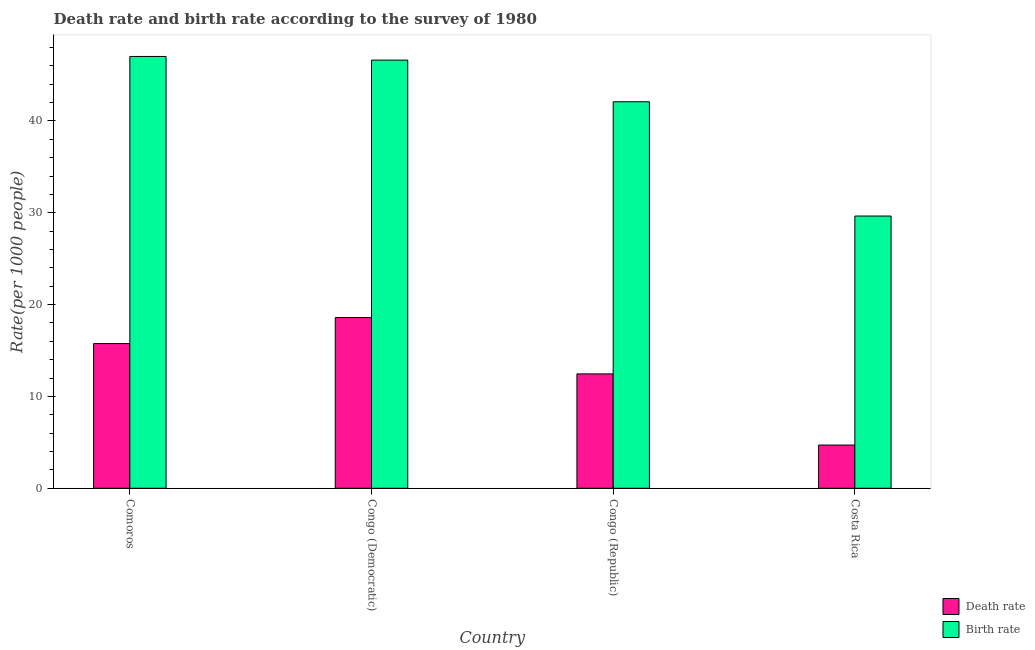Are the number of bars per tick equal to the number of legend labels?
Your answer should be very brief. Yes. Are the number of bars on each tick of the X-axis equal?
Your answer should be compact. Yes. How many bars are there on the 1st tick from the right?
Offer a very short reply. 2. What is the label of the 4th group of bars from the left?
Ensure brevity in your answer.  Costa Rica. What is the death rate in Costa Rica?
Offer a very short reply. 4.71. Across all countries, what is the maximum birth rate?
Ensure brevity in your answer.  47.03. Across all countries, what is the minimum death rate?
Ensure brevity in your answer.  4.71. In which country was the birth rate maximum?
Give a very brief answer. Comoros. What is the total birth rate in the graph?
Your answer should be compact. 165.4. What is the difference between the birth rate in Congo (Democratic) and that in Congo (Republic)?
Provide a short and direct response. 4.53. What is the difference between the death rate in Congo (Republic) and the birth rate in Costa Rica?
Your response must be concise. -17.19. What is the average birth rate per country?
Your answer should be very brief. 41.35. What is the difference between the death rate and birth rate in Comoros?
Offer a very short reply. -31.27. In how many countries, is the birth rate greater than 36 ?
Provide a short and direct response. 3. What is the ratio of the death rate in Comoros to that in Congo (Democratic)?
Your answer should be very brief. 0.85. What is the difference between the highest and the second highest birth rate?
Give a very brief answer. 0.4. What is the difference between the highest and the lowest birth rate?
Provide a short and direct response. 17.38. What does the 1st bar from the left in Congo (Democratic) represents?
Your response must be concise. Death rate. What does the 2nd bar from the right in Congo (Republic) represents?
Your answer should be very brief. Death rate. Are all the bars in the graph horizontal?
Ensure brevity in your answer.  No. How many countries are there in the graph?
Your answer should be very brief. 4. What is the difference between two consecutive major ticks on the Y-axis?
Your answer should be compact. 10. Does the graph contain any zero values?
Your response must be concise. No. Does the graph contain grids?
Offer a terse response. No. Where does the legend appear in the graph?
Offer a very short reply. Bottom right. How are the legend labels stacked?
Provide a short and direct response. Vertical. What is the title of the graph?
Keep it short and to the point. Death rate and birth rate according to the survey of 1980. Does "Agricultural land" appear as one of the legend labels in the graph?
Provide a succinct answer. No. What is the label or title of the Y-axis?
Offer a very short reply. Rate(per 1000 people). What is the Rate(per 1000 people) of Death rate in Comoros?
Give a very brief answer. 15.76. What is the Rate(per 1000 people) in Birth rate in Comoros?
Offer a very short reply. 47.03. What is the Rate(per 1000 people) in Death rate in Congo (Democratic)?
Ensure brevity in your answer.  18.6. What is the Rate(per 1000 people) of Birth rate in Congo (Democratic)?
Offer a terse response. 46.63. What is the Rate(per 1000 people) of Death rate in Congo (Republic)?
Provide a short and direct response. 12.46. What is the Rate(per 1000 people) of Birth rate in Congo (Republic)?
Provide a succinct answer. 42.09. What is the Rate(per 1000 people) of Death rate in Costa Rica?
Your answer should be compact. 4.71. What is the Rate(per 1000 people) in Birth rate in Costa Rica?
Offer a very short reply. 29.65. Across all countries, what is the maximum Rate(per 1000 people) in Death rate?
Ensure brevity in your answer.  18.6. Across all countries, what is the maximum Rate(per 1000 people) in Birth rate?
Your response must be concise. 47.03. Across all countries, what is the minimum Rate(per 1000 people) of Death rate?
Your answer should be very brief. 4.71. Across all countries, what is the minimum Rate(per 1000 people) of Birth rate?
Your answer should be compact. 29.65. What is the total Rate(per 1000 people) of Death rate in the graph?
Ensure brevity in your answer.  51.52. What is the total Rate(per 1000 people) in Birth rate in the graph?
Provide a short and direct response. 165.4. What is the difference between the Rate(per 1000 people) in Death rate in Comoros and that in Congo (Democratic)?
Offer a terse response. -2.84. What is the difference between the Rate(per 1000 people) of Birth rate in Comoros and that in Congo (Democratic)?
Give a very brief answer. 0.4. What is the difference between the Rate(per 1000 people) in Death rate in Comoros and that in Congo (Republic)?
Your answer should be compact. 3.3. What is the difference between the Rate(per 1000 people) in Birth rate in Comoros and that in Congo (Republic)?
Your answer should be compact. 4.93. What is the difference between the Rate(per 1000 people) in Death rate in Comoros and that in Costa Rica?
Give a very brief answer. 11.05. What is the difference between the Rate(per 1000 people) in Birth rate in Comoros and that in Costa Rica?
Your response must be concise. 17.38. What is the difference between the Rate(per 1000 people) of Death rate in Congo (Democratic) and that in Congo (Republic)?
Ensure brevity in your answer.  6.14. What is the difference between the Rate(per 1000 people) of Birth rate in Congo (Democratic) and that in Congo (Republic)?
Provide a short and direct response. 4.54. What is the difference between the Rate(per 1000 people) of Death rate in Congo (Democratic) and that in Costa Rica?
Provide a succinct answer. 13.89. What is the difference between the Rate(per 1000 people) of Birth rate in Congo (Democratic) and that in Costa Rica?
Keep it short and to the point. 16.98. What is the difference between the Rate(per 1000 people) in Death rate in Congo (Republic) and that in Costa Rica?
Your answer should be very brief. 7.75. What is the difference between the Rate(per 1000 people) of Birth rate in Congo (Republic) and that in Costa Rica?
Your answer should be compact. 12.45. What is the difference between the Rate(per 1000 people) of Death rate in Comoros and the Rate(per 1000 people) of Birth rate in Congo (Democratic)?
Provide a succinct answer. -30.87. What is the difference between the Rate(per 1000 people) of Death rate in Comoros and the Rate(per 1000 people) of Birth rate in Congo (Republic)?
Provide a succinct answer. -26.34. What is the difference between the Rate(per 1000 people) of Death rate in Comoros and the Rate(per 1000 people) of Birth rate in Costa Rica?
Make the answer very short. -13.89. What is the difference between the Rate(per 1000 people) of Death rate in Congo (Democratic) and the Rate(per 1000 people) of Birth rate in Congo (Republic)?
Your response must be concise. -23.5. What is the difference between the Rate(per 1000 people) in Death rate in Congo (Democratic) and the Rate(per 1000 people) in Birth rate in Costa Rica?
Ensure brevity in your answer.  -11.05. What is the difference between the Rate(per 1000 people) of Death rate in Congo (Republic) and the Rate(per 1000 people) of Birth rate in Costa Rica?
Provide a short and direct response. -17.19. What is the average Rate(per 1000 people) of Death rate per country?
Ensure brevity in your answer.  12.88. What is the average Rate(per 1000 people) in Birth rate per country?
Offer a very short reply. 41.35. What is the difference between the Rate(per 1000 people) in Death rate and Rate(per 1000 people) in Birth rate in Comoros?
Make the answer very short. -31.27. What is the difference between the Rate(per 1000 people) of Death rate and Rate(per 1000 people) of Birth rate in Congo (Democratic)?
Offer a terse response. -28.03. What is the difference between the Rate(per 1000 people) in Death rate and Rate(per 1000 people) in Birth rate in Congo (Republic)?
Provide a succinct answer. -29.64. What is the difference between the Rate(per 1000 people) of Death rate and Rate(per 1000 people) of Birth rate in Costa Rica?
Your answer should be compact. -24.94. What is the ratio of the Rate(per 1000 people) of Death rate in Comoros to that in Congo (Democratic)?
Offer a terse response. 0.85. What is the ratio of the Rate(per 1000 people) in Birth rate in Comoros to that in Congo (Democratic)?
Offer a terse response. 1.01. What is the ratio of the Rate(per 1000 people) in Death rate in Comoros to that in Congo (Republic)?
Ensure brevity in your answer.  1.27. What is the ratio of the Rate(per 1000 people) of Birth rate in Comoros to that in Congo (Republic)?
Your answer should be very brief. 1.12. What is the ratio of the Rate(per 1000 people) of Death rate in Comoros to that in Costa Rica?
Provide a short and direct response. 3.35. What is the ratio of the Rate(per 1000 people) in Birth rate in Comoros to that in Costa Rica?
Keep it short and to the point. 1.59. What is the ratio of the Rate(per 1000 people) of Death rate in Congo (Democratic) to that in Congo (Republic)?
Your answer should be compact. 1.49. What is the ratio of the Rate(per 1000 people) in Birth rate in Congo (Democratic) to that in Congo (Republic)?
Your answer should be compact. 1.11. What is the ratio of the Rate(per 1000 people) of Death rate in Congo (Democratic) to that in Costa Rica?
Provide a short and direct response. 3.95. What is the ratio of the Rate(per 1000 people) in Birth rate in Congo (Democratic) to that in Costa Rica?
Provide a short and direct response. 1.57. What is the ratio of the Rate(per 1000 people) of Death rate in Congo (Republic) to that in Costa Rica?
Ensure brevity in your answer.  2.65. What is the ratio of the Rate(per 1000 people) of Birth rate in Congo (Republic) to that in Costa Rica?
Make the answer very short. 1.42. What is the difference between the highest and the second highest Rate(per 1000 people) in Death rate?
Ensure brevity in your answer.  2.84. What is the difference between the highest and the second highest Rate(per 1000 people) in Birth rate?
Your response must be concise. 0.4. What is the difference between the highest and the lowest Rate(per 1000 people) in Death rate?
Your response must be concise. 13.89. What is the difference between the highest and the lowest Rate(per 1000 people) of Birth rate?
Keep it short and to the point. 17.38. 